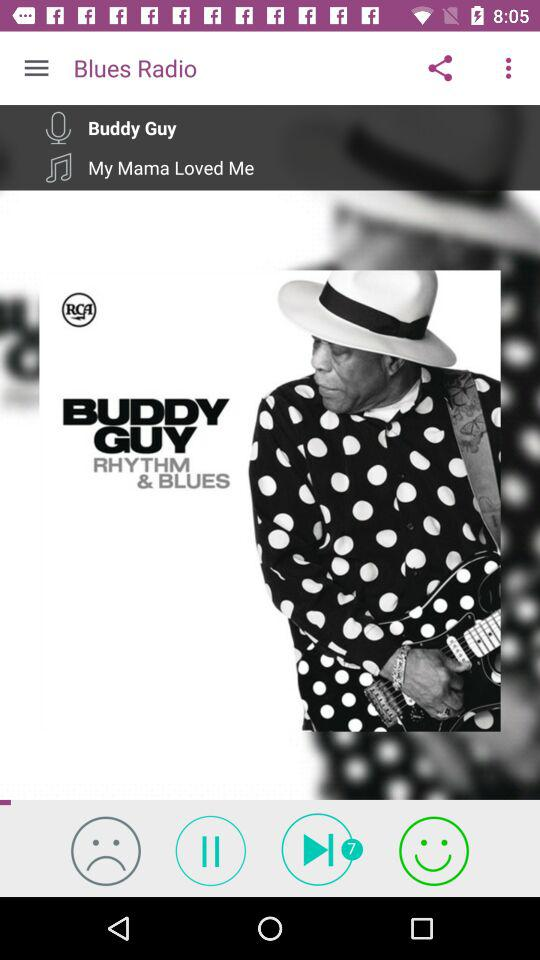What is the application name? The application name is Blues Radio. 